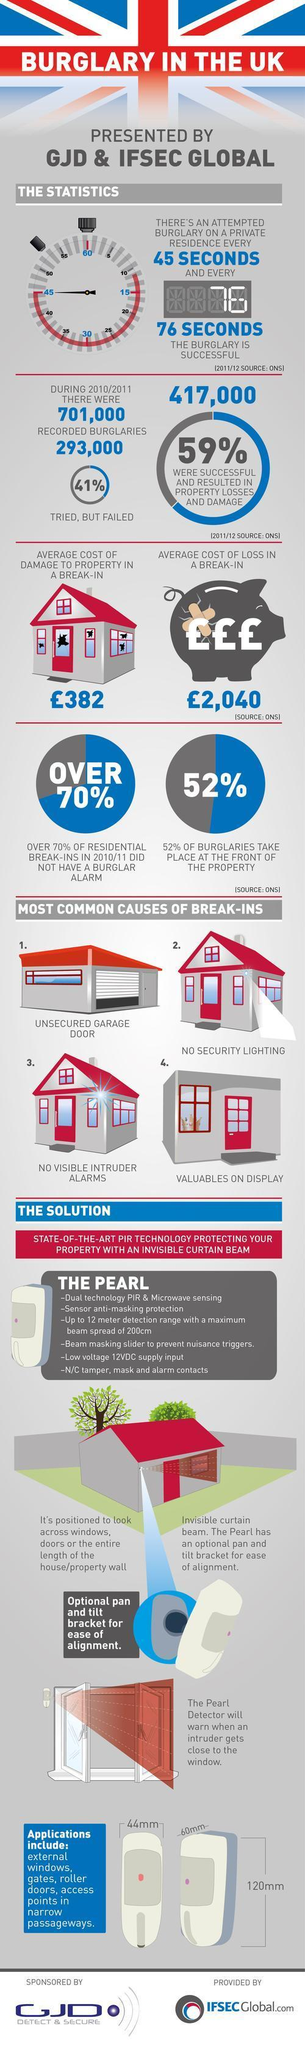What is the average cost of loss in a break-in in UK?
Answer the question with a short phrase. £2,040 What percentage of burglaries in UK take place at the front of the property? 52% How many burglaries in UK were successful & resulted in property losses & damage during 2010/2011? 417,000 What percentage of burglaries in UK failed after trying during 2010/2011? 41% 